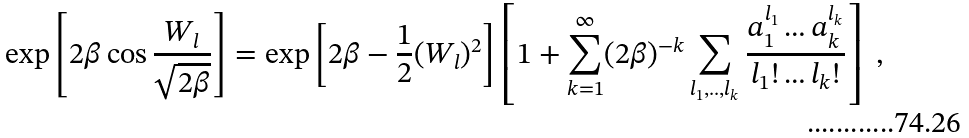<formula> <loc_0><loc_0><loc_500><loc_500>\exp \left [ 2 \beta \cos \frac { W _ { l } } { \sqrt { 2 \beta } } \right ] = \exp \left [ 2 \beta - \frac { 1 } { 2 } ( W _ { l } ) ^ { 2 } \right ] \left [ 1 + \sum _ { k = 1 } ^ { \infty } ( 2 \beta ) ^ { - k } \sum _ { l _ { 1 } , . . , l _ { k } } \frac { a _ { 1 } ^ { l _ { 1 } } \dots a _ { k } ^ { l _ { k } } } { l _ { 1 } ! \dots l _ { k } ! } \right ] \ ,</formula> 